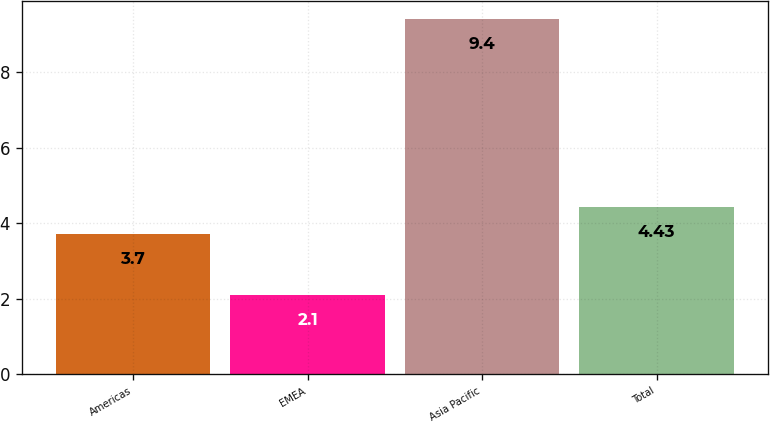Convert chart to OTSL. <chart><loc_0><loc_0><loc_500><loc_500><bar_chart><fcel>Americas<fcel>EMEA<fcel>Asia Pacific<fcel>Total<nl><fcel>3.7<fcel>2.1<fcel>9.4<fcel>4.43<nl></chart> 